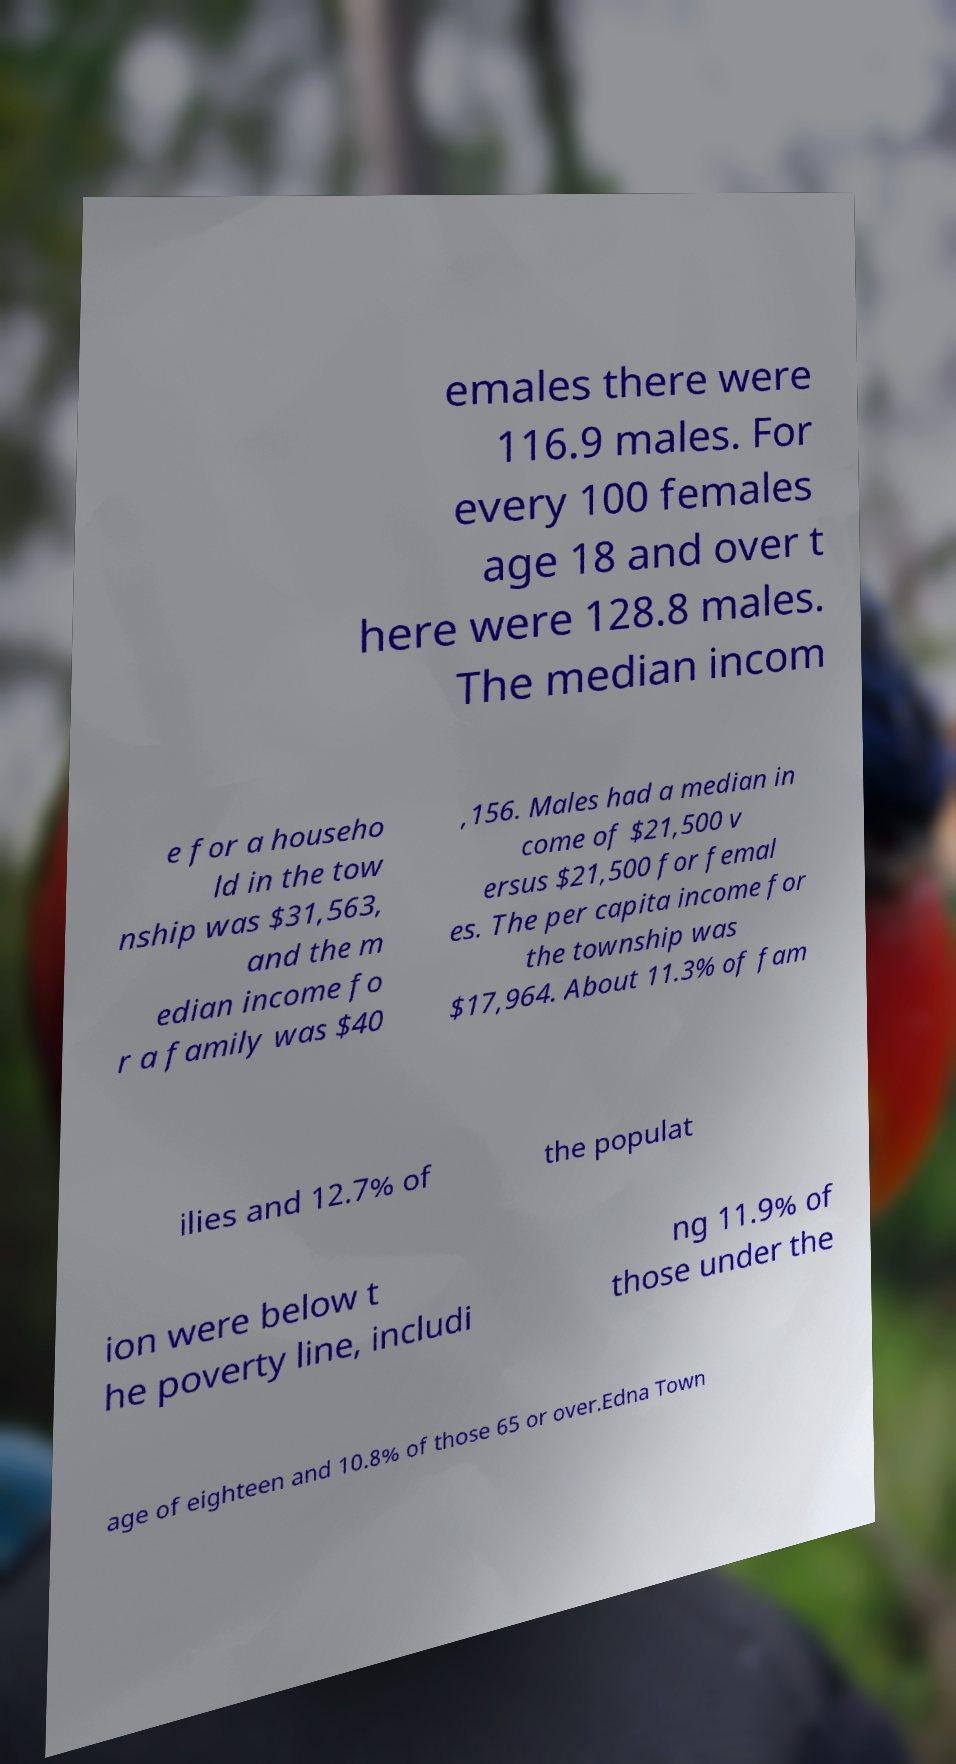For documentation purposes, I need the text within this image transcribed. Could you provide that? emales there were 116.9 males. For every 100 females age 18 and over t here were 128.8 males. The median incom e for a househo ld in the tow nship was $31,563, and the m edian income fo r a family was $40 ,156. Males had a median in come of $21,500 v ersus $21,500 for femal es. The per capita income for the township was $17,964. About 11.3% of fam ilies and 12.7% of the populat ion were below t he poverty line, includi ng 11.9% of those under the age of eighteen and 10.8% of those 65 or over.Edna Town 